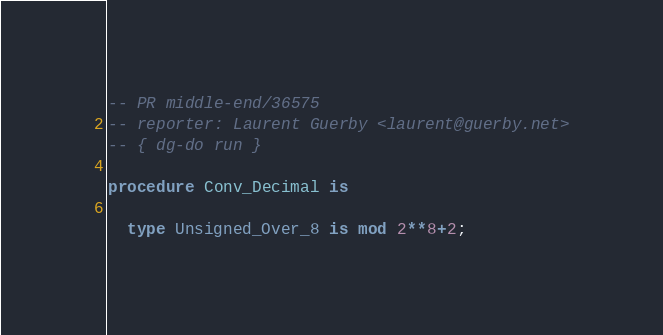Convert code to text. <code><loc_0><loc_0><loc_500><loc_500><_Ada_>-- PR middle-end/36575
-- reporter: Laurent Guerby <laurent@guerby.net>
-- { dg-do run }

procedure Conv_Decimal is

  type Unsigned_Over_8 is mod 2**8+2;</code> 